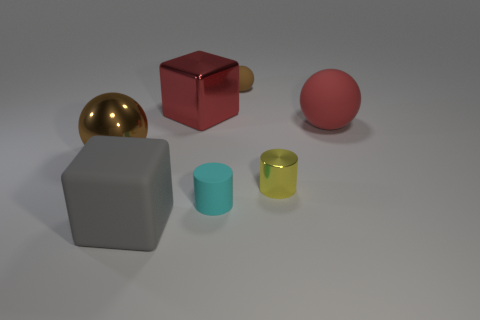How many things are either brown objects that are behind the small cyan matte object or large objects on the right side of the big metallic sphere?
Your answer should be very brief. 5. Are there fewer red objects that are right of the tiny brown matte object than large blue things?
Your response must be concise. No. Are there any other red metal cubes of the same size as the red cube?
Provide a succinct answer. No. What color is the tiny shiny thing?
Ensure brevity in your answer.  Yellow. Is the red matte sphere the same size as the yellow thing?
Keep it short and to the point. No. How many things are either blue rubber objects or big red rubber spheres?
Offer a terse response. 1. Is the number of large brown spheres that are left of the large brown sphere the same as the number of big metallic objects?
Give a very brief answer. No. Is there a big red metallic cube in front of the cyan matte cylinder to the right of the big matte thing on the left side of the small yellow shiny object?
Provide a short and direct response. No. What is the color of the big cube that is the same material as the small cyan thing?
Your answer should be compact. Gray. Does the metal thing in front of the brown metal object have the same color as the matte cube?
Give a very brief answer. No. 